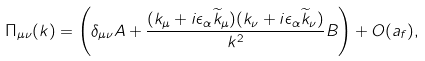<formula> <loc_0><loc_0><loc_500><loc_500>\Pi _ { \mu \nu } ( k ) = \left ( \delta _ { \mu \nu } A + \frac { ( k _ { \mu } + i \epsilon _ { \alpha } \widetilde { k } _ { \mu } ) ( k _ { \nu } + i \epsilon _ { \alpha } \widetilde { k } _ { \nu } ) } { k ^ { 2 } } B \right ) + O ( a _ { f } ) ,</formula> 